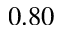<formula> <loc_0><loc_0><loc_500><loc_500>0 . 8 0</formula> 